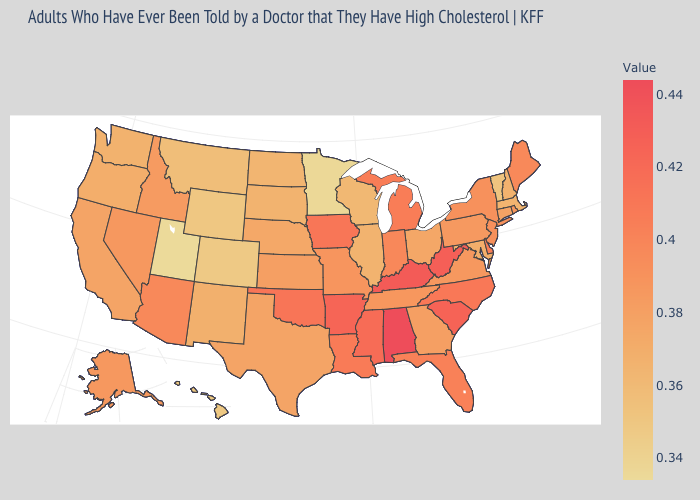Which states have the highest value in the USA?
Be succinct. Alabama. Among the states that border North Dakota , does Minnesota have the lowest value?
Short answer required. Yes. Among the states that border Missouri , does Nebraska have the lowest value?
Write a very short answer. No. Does Alabama have the highest value in the USA?
Concise answer only. Yes. Among the states that border Oregon , does Idaho have the highest value?
Concise answer only. No. Is the legend a continuous bar?
Quick response, please. Yes. Which states hav the highest value in the MidWest?
Write a very short answer. Iowa. Among the states that border Iowa , which have the lowest value?
Concise answer only. Minnesota. Among the states that border Virginia , does West Virginia have the lowest value?
Short answer required. No. 